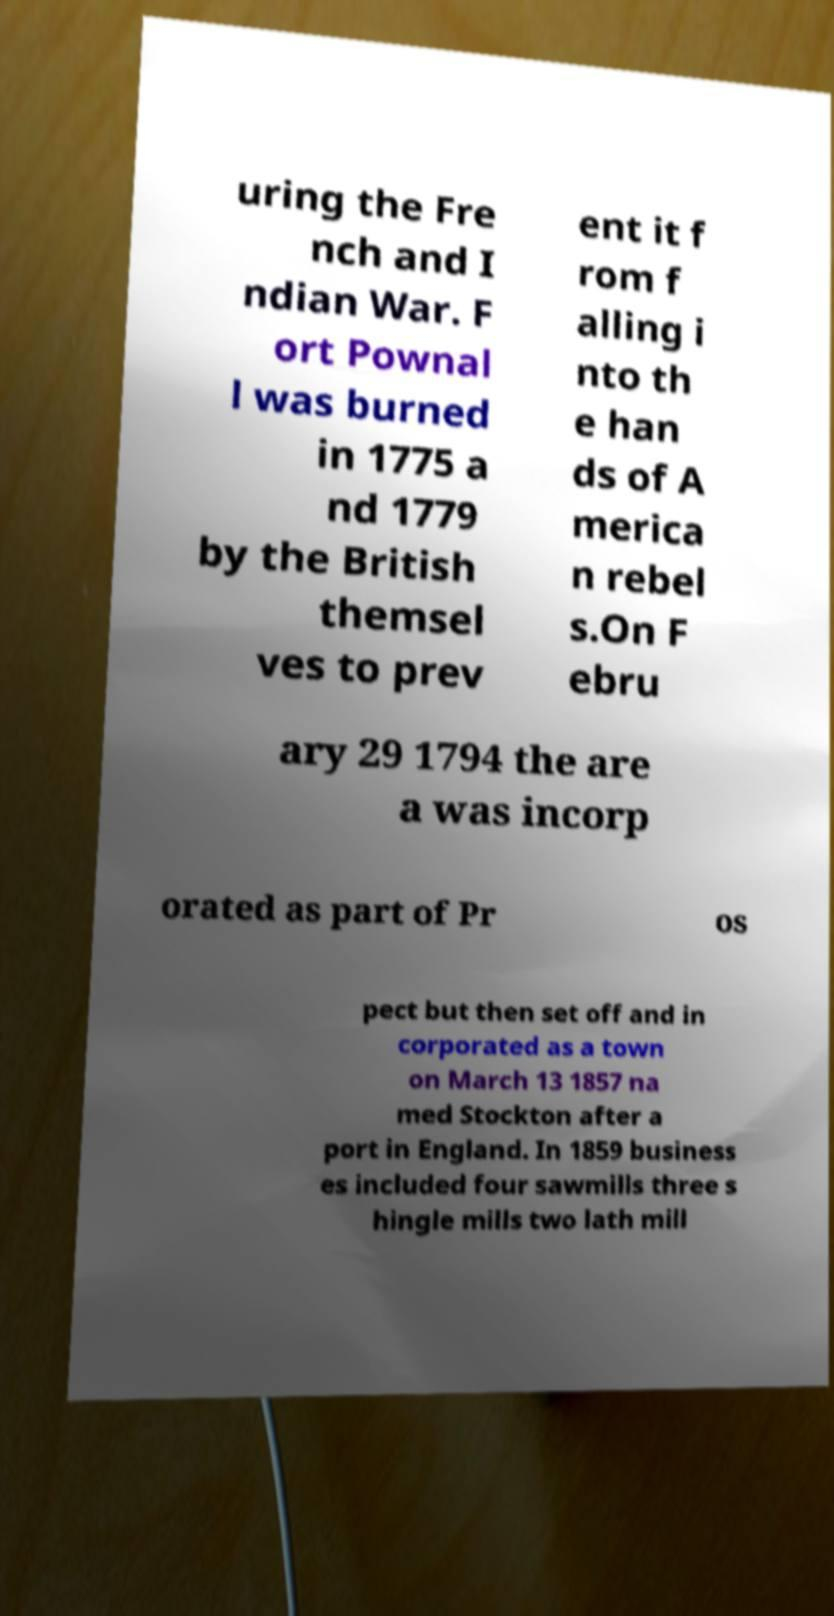Please identify and transcribe the text found in this image. uring the Fre nch and I ndian War. F ort Pownal l was burned in 1775 a nd 1779 by the British themsel ves to prev ent it f rom f alling i nto th e han ds of A merica n rebel s.On F ebru ary 29 1794 the are a was incorp orated as part of Pr os pect but then set off and in corporated as a town on March 13 1857 na med Stockton after a port in England. In 1859 business es included four sawmills three s hingle mills two lath mill 